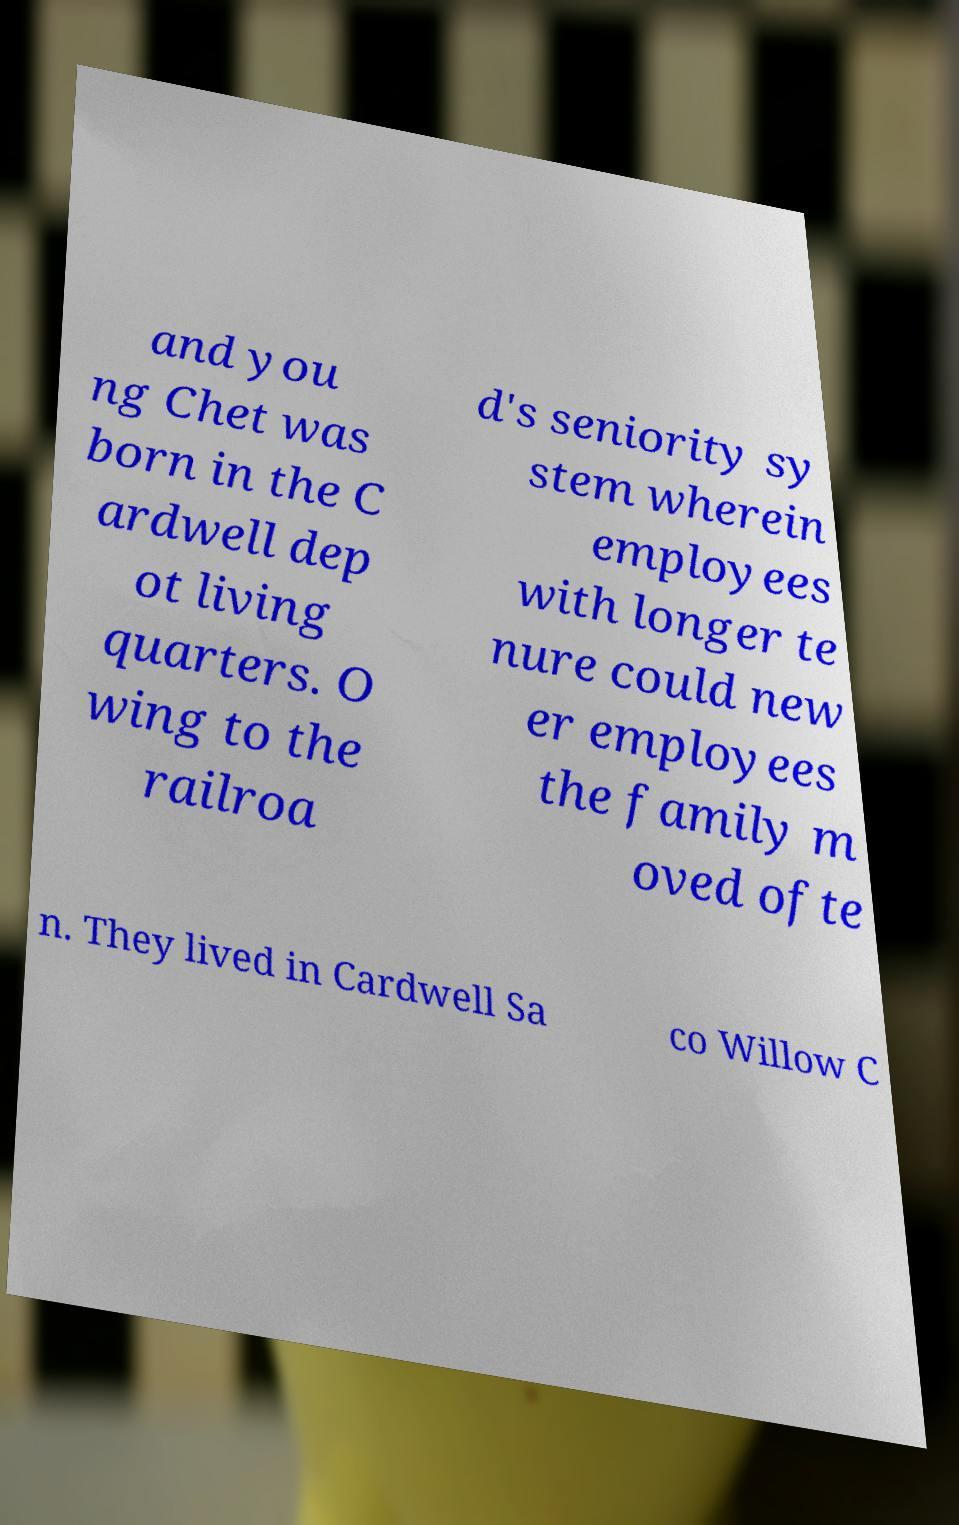Please read and relay the text visible in this image. What does it say? and you ng Chet was born in the C ardwell dep ot living quarters. O wing to the railroa d's seniority sy stem wherein employees with longer te nure could new er employees the family m oved ofte n. They lived in Cardwell Sa co Willow C 